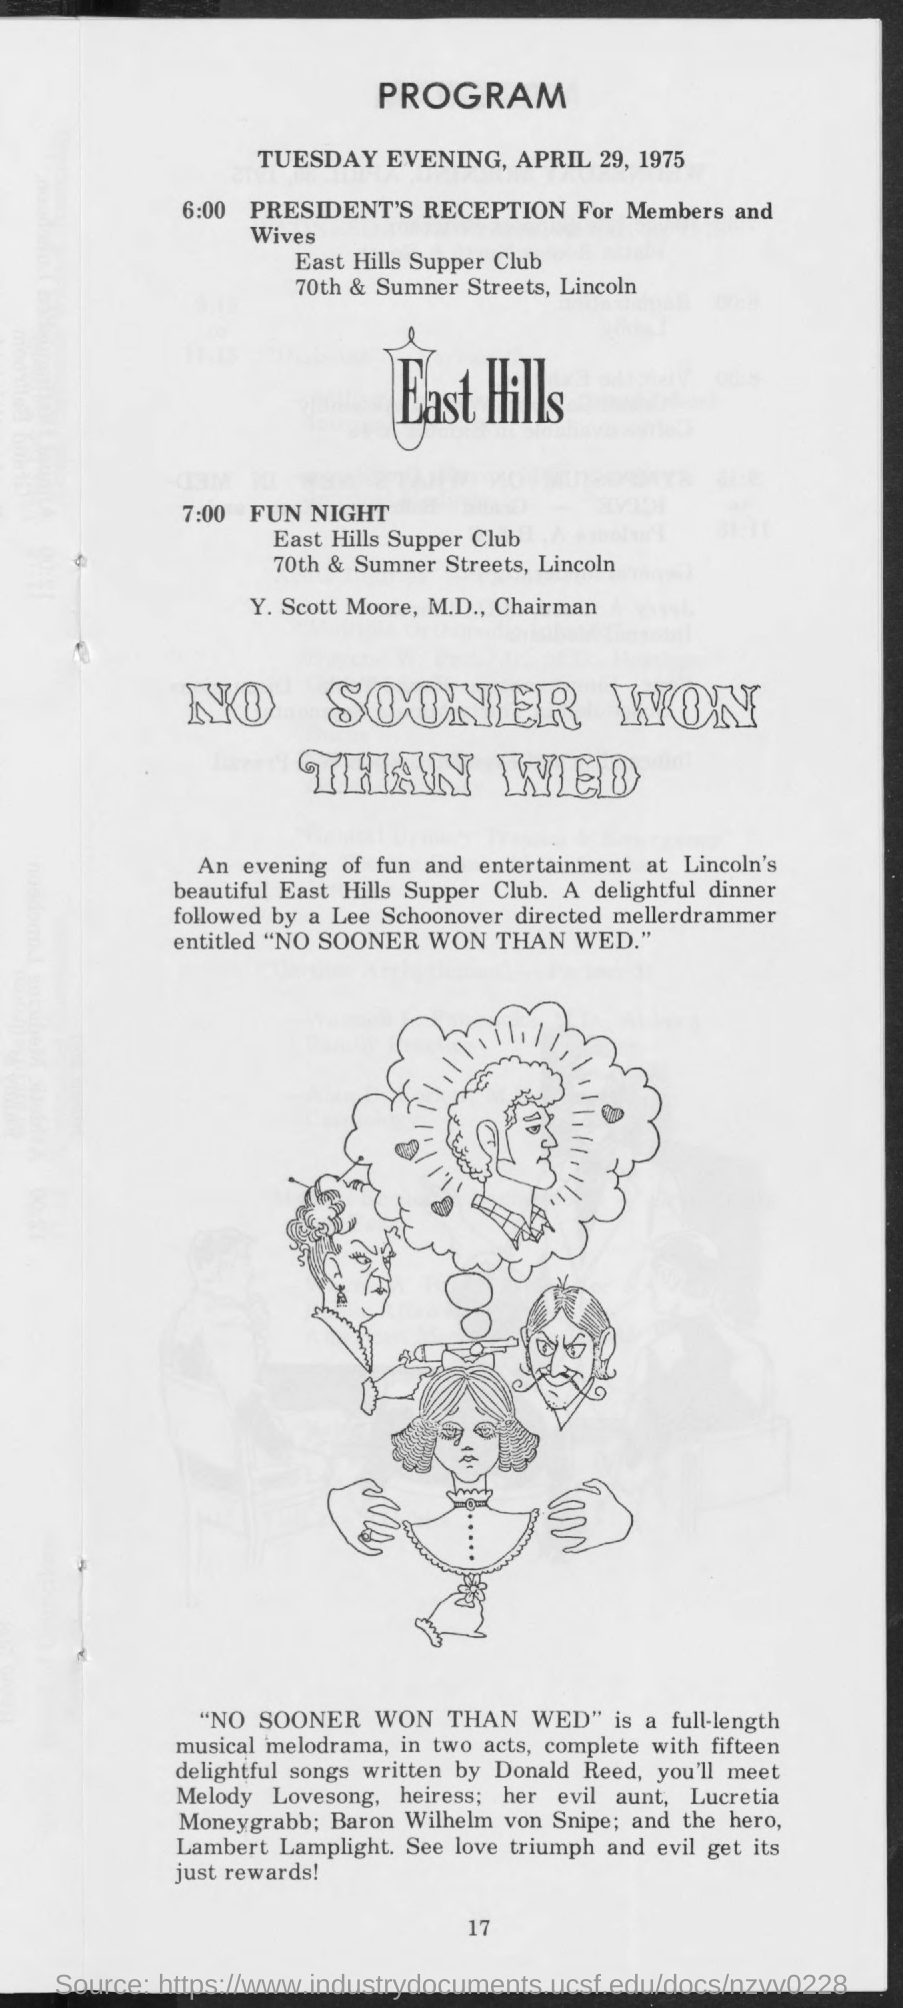Give some essential details in this illustration. At 6:00, there will be a President's Reception for Members and their Wives. Lee Schoonover has directed the melodrammer. The mellerdrammer's name is 'NO SOONER WON THAN WED' The event known as "FUN NIGHT" is scheduled to take place at the East Hills Supper Club. The author of the songs is Donald Reed. 